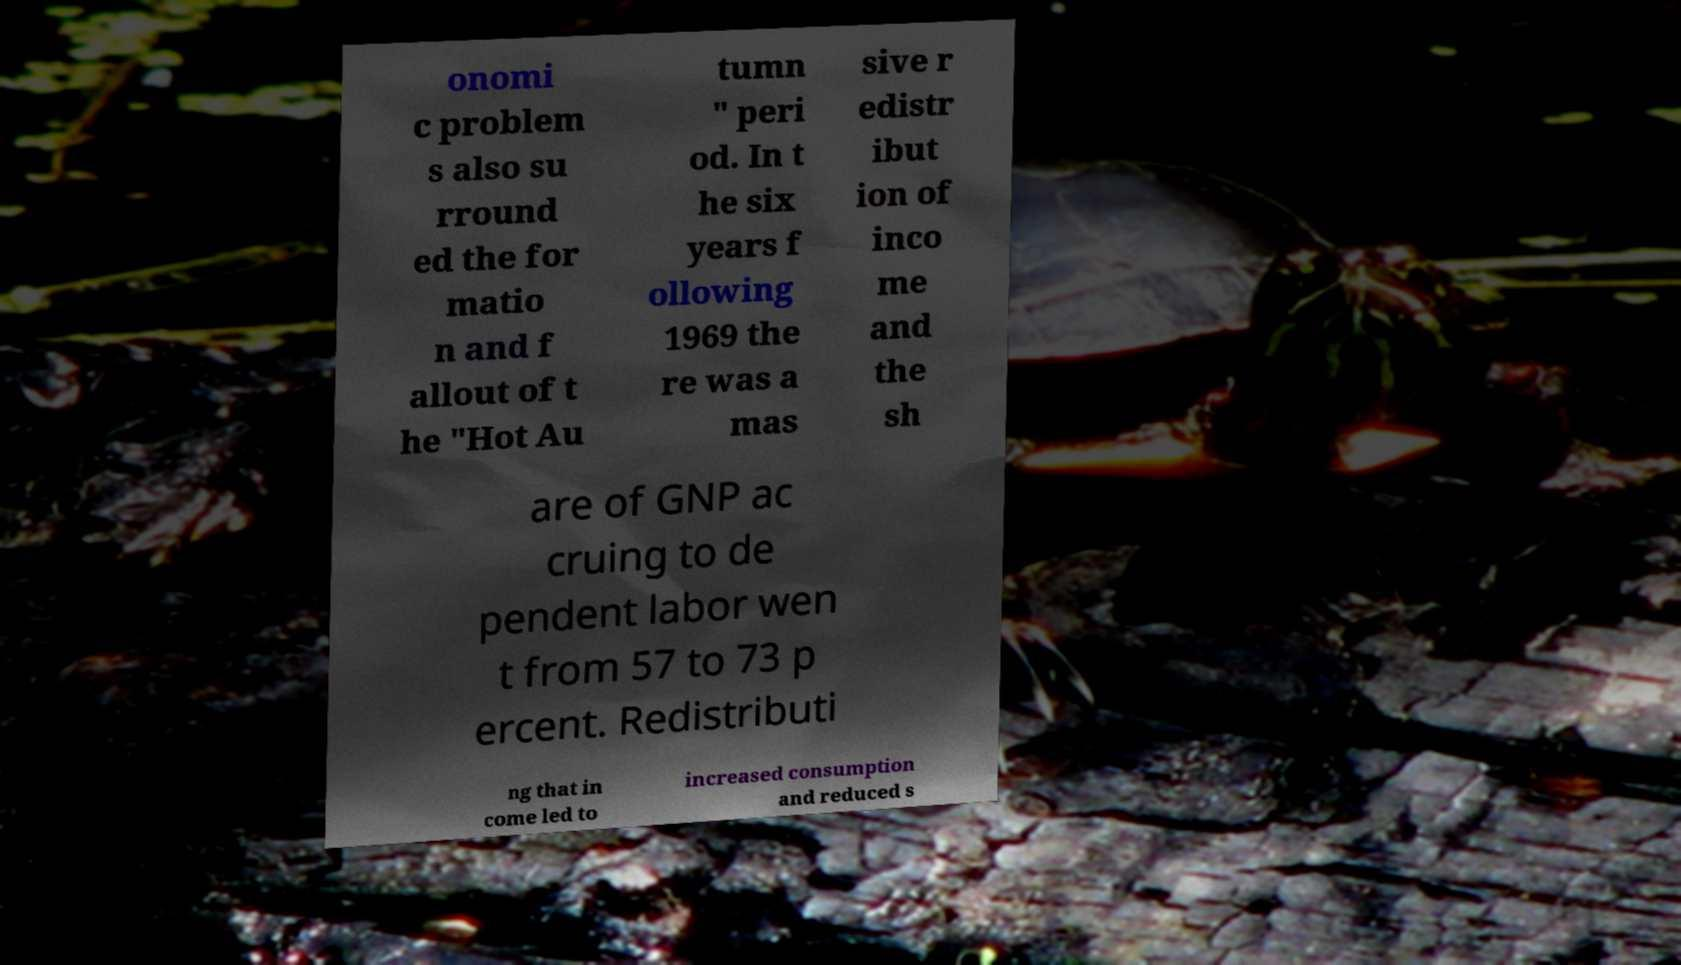For documentation purposes, I need the text within this image transcribed. Could you provide that? onomi c problem s also su rround ed the for matio n and f allout of t he "Hot Au tumn " peri od. In t he six years f ollowing 1969 the re was a mas sive r edistr ibut ion of inco me and the sh are of GNP ac cruing to de pendent labor wen t from 57 to 73 p ercent. Redistributi ng that in come led to increased consumption and reduced s 